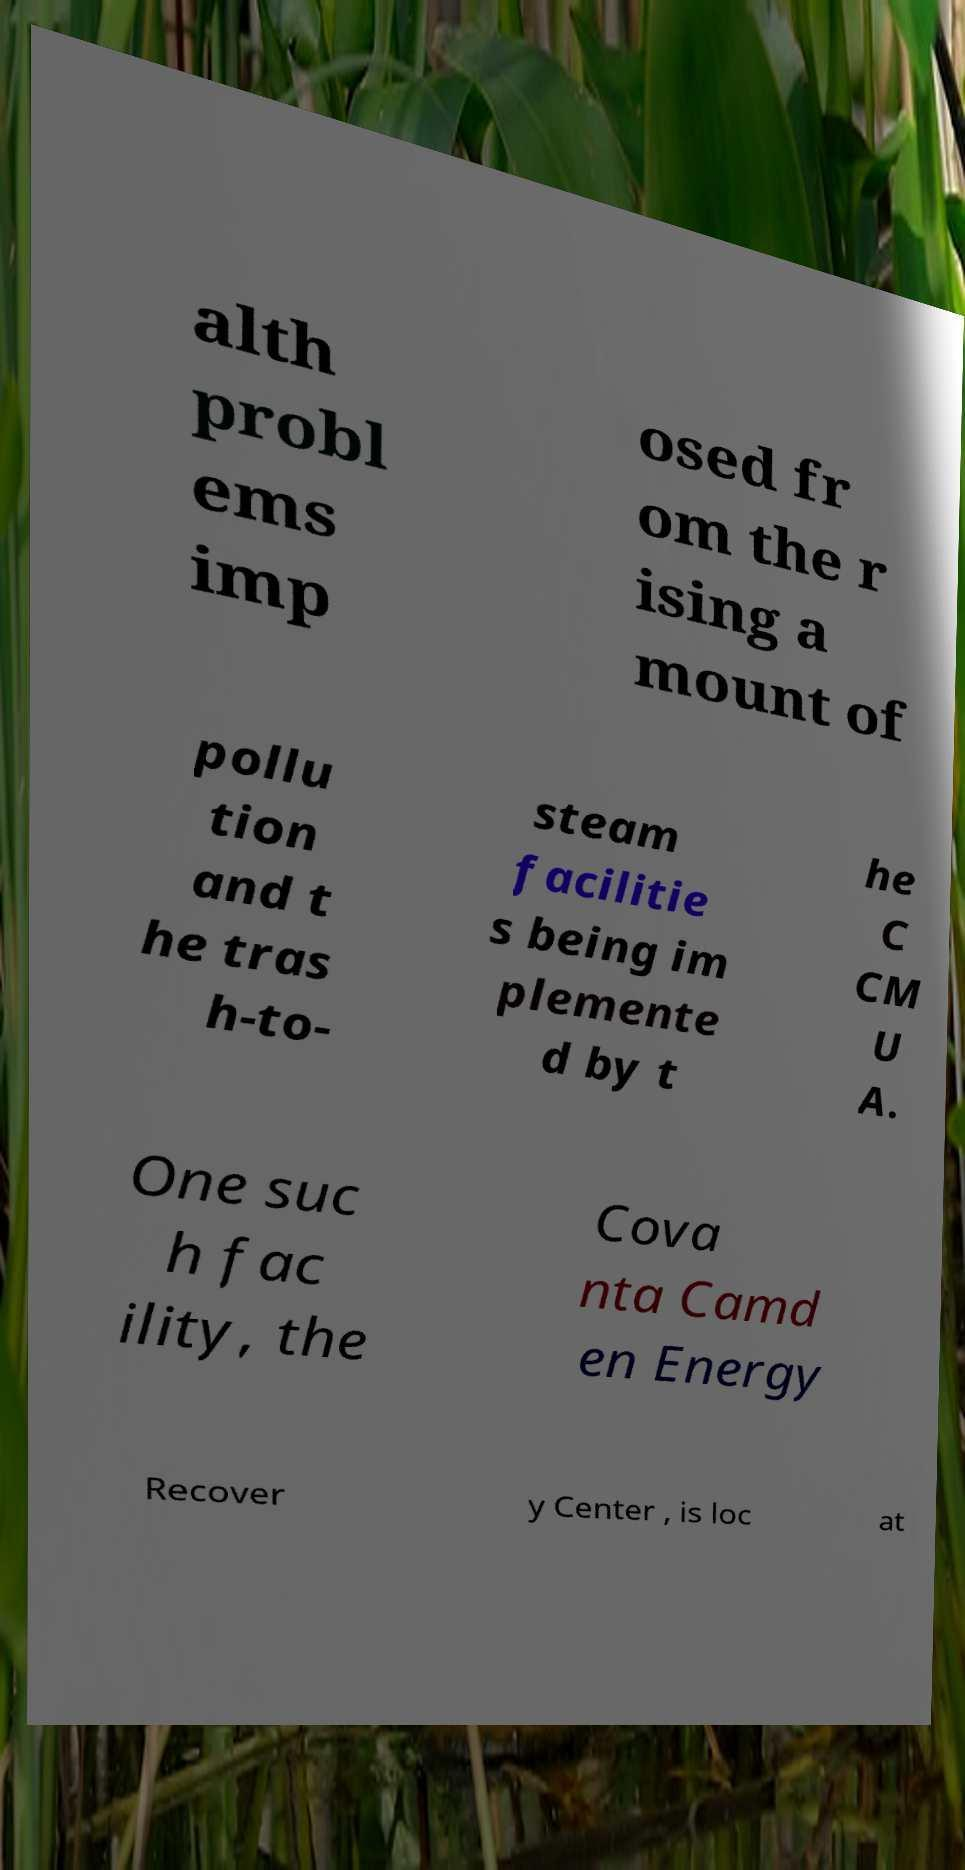For documentation purposes, I need the text within this image transcribed. Could you provide that? alth probl ems imp osed fr om the r ising a mount of pollu tion and t he tras h-to- steam facilitie s being im plemente d by t he C CM U A. One suc h fac ility, the Cova nta Camd en Energy Recover y Center , is loc at 